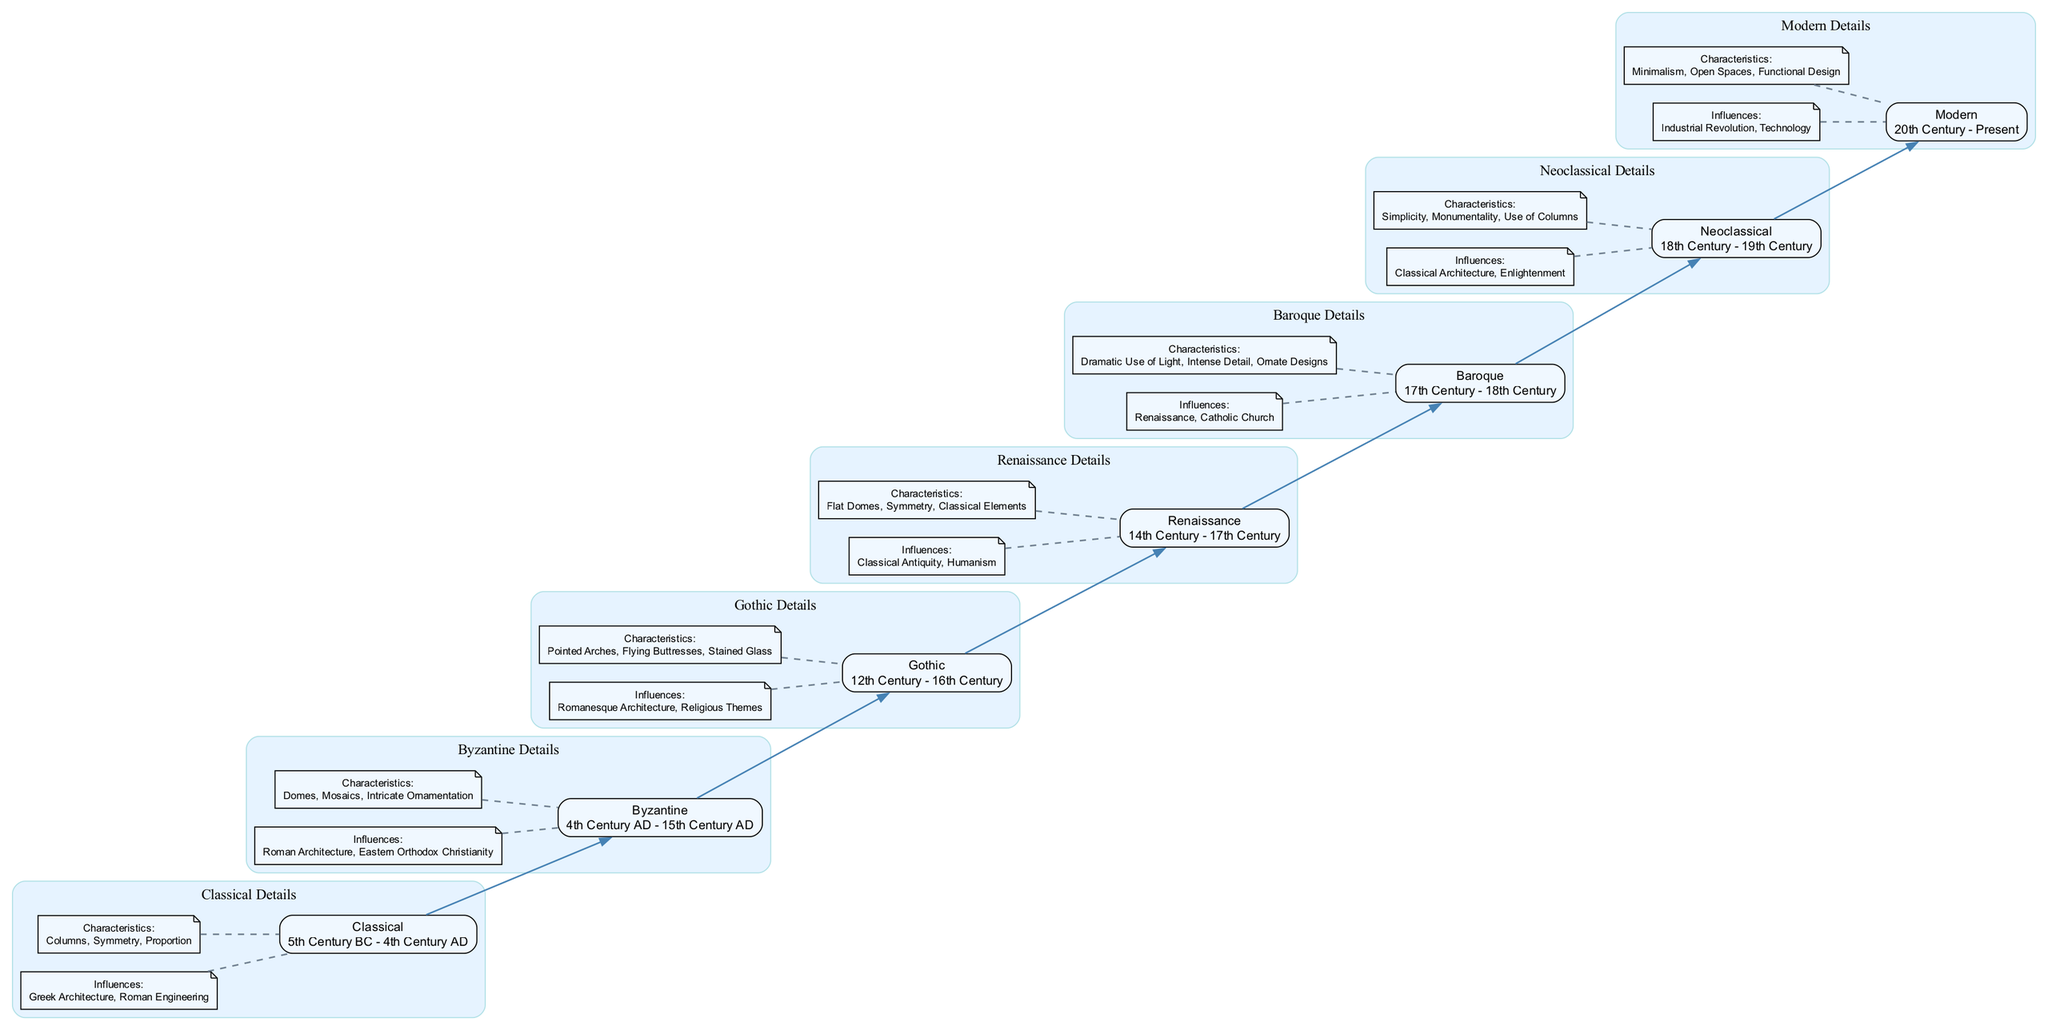What is the period of the Gothic architectural style? The Gothic style is defined in the diagram as spanning from the 12th Century to the 16th Century. This information is typically found directly below the style name in the nodes.
Answer: 12th Century - 16th Century Which architectural style directly precedes the Baroque style? In the flow chart, the direct connection or edge can be followed from the Renaissance style to the Baroque style, indicating Renaissance comes immediately before Baroque.
Answer: Renaissance How many key influences does the Neoclassical style have? The Neoclassical style has two key influences listed, which can be counted by examining the "Key Influences" section specific to the Neoclassical style in its subgraph.
Answer: 2 What characteristic is unique to the Modern architectural style? The diagram specifies characteristics, and of these, "Functional Design" is particularly highlighted because it distinguishes Modern architecture from the preceding styles, indicating a significant shift in focus.
Answer: Functional Design What is the relationship between Byzantine and Gothic styles? The flow chart shows a direct edge from Byzantine to Gothic, indicating that Gothic style evolved from Byzantine influences, marking a chronological flow of architectural styles.
Answer: Evolved from Which architectural style is characterized by the use of columns? Upon analyzing the characteristics listed in the diagram, the Neoclassical architectural style explicitly mentions the use of columns, which is a significant detail connected to its identity.
Answer: Neoclassical How many architectural styles does the flow chart cover? By counting each distinct style listed in the flow chart, one can determine that there are a total of seven architectural styles represented throughout the diagram.
Answer: 7 What major technological influence shaped Modern architecture? The diagram indicates that the Industrial Revolution significantly influenced Modern architecture, which is a key factor in its development as shown in the key influences section.
Answer: Industrial Revolution Which style introduced the dramatic use of light? The Baroque architectural style is mentioned specifically for its characteristic of "Dramatic Use of Light," as identified in the characteristics subgraph for Baroque style.
Answer: Baroque What time period does the Renaissance style cover? According to the flow chart, the period for the Renaissance style is stated to be from the 14th Century to the 17th Century; this information is typically housed in the format of period listing within its node.
Answer: 14th Century - 17th Century 